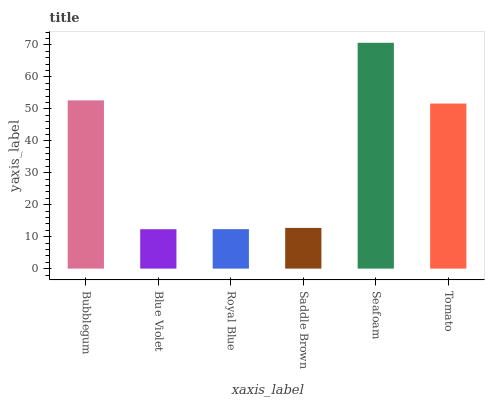Is Blue Violet the minimum?
Answer yes or no. Yes. Is Seafoam the maximum?
Answer yes or no. Yes. Is Royal Blue the minimum?
Answer yes or no. No. Is Royal Blue the maximum?
Answer yes or no. No. Is Royal Blue greater than Blue Violet?
Answer yes or no. Yes. Is Blue Violet less than Royal Blue?
Answer yes or no. Yes. Is Blue Violet greater than Royal Blue?
Answer yes or no. No. Is Royal Blue less than Blue Violet?
Answer yes or no. No. Is Tomato the high median?
Answer yes or no. Yes. Is Saddle Brown the low median?
Answer yes or no. Yes. Is Saddle Brown the high median?
Answer yes or no. No. Is Royal Blue the low median?
Answer yes or no. No. 